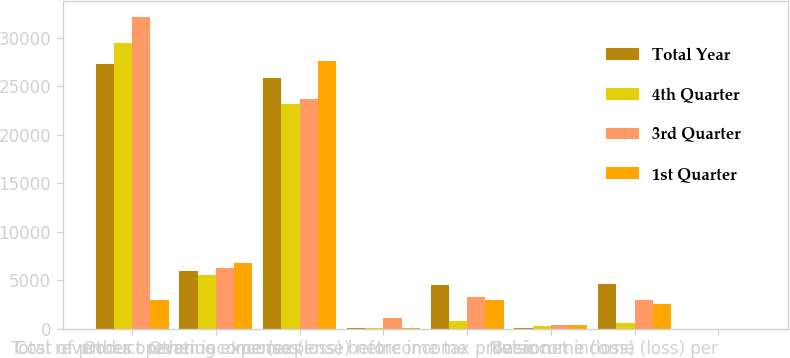Convert chart to OTSL. <chart><loc_0><loc_0><loc_500><loc_500><stacked_bar_chart><ecel><fcel>Total revenues<fcel>Cost of product revenue<fcel>Other operating expenses<fcel>Other income (expense) net<fcel>Income (loss) before income<fcel>Income tax provision<fcel>Net income (loss)<fcel>Basic net income (loss) per<nl><fcel>Total Year<fcel>27355<fcel>5891<fcel>25885<fcel>77<fcel>4498<fcel>96<fcel>4594<fcel>0.12<nl><fcel>4th Quarter<fcel>29478<fcel>5551<fcel>23161<fcel>60<fcel>826<fcel>225<fcel>601<fcel>0.02<nl><fcel>3rd Quarter<fcel>32198<fcel>6279<fcel>23686<fcel>1054<fcel>3287<fcel>366<fcel>2921<fcel>0.08<nl><fcel>1st Quarter<fcel>2921<fcel>6786<fcel>27616<fcel>14<fcel>2928<fcel>361<fcel>2567<fcel>0.07<nl></chart> 